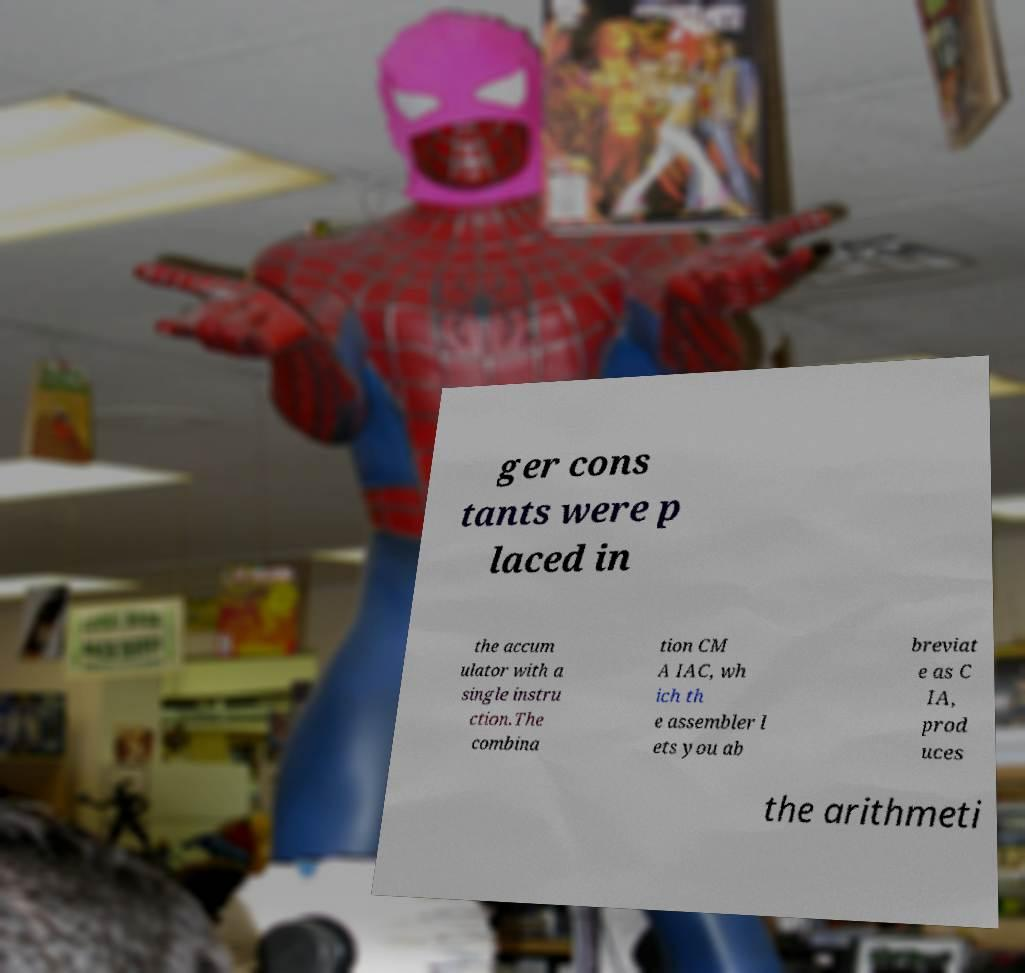There's text embedded in this image that I need extracted. Can you transcribe it verbatim? ger cons tants were p laced in the accum ulator with a single instru ction.The combina tion CM A IAC, wh ich th e assembler l ets you ab breviat e as C IA, prod uces the arithmeti 